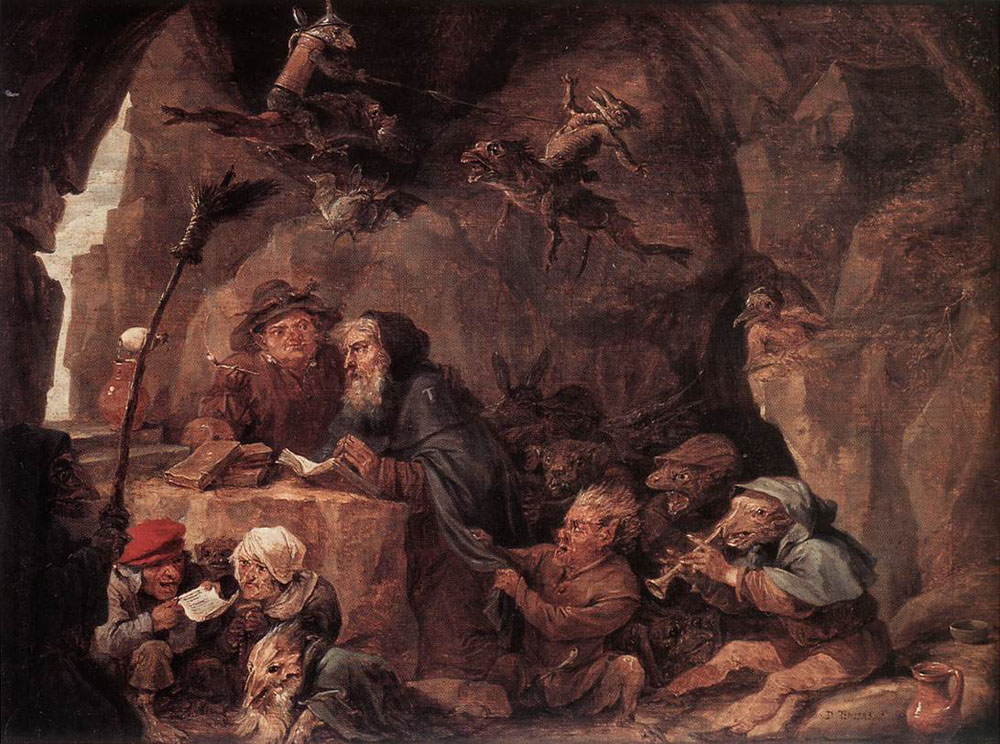How does the light play a role in this particular painting? The use of light is pivotal in this painting, typical of the Baroque period's style. Strategic placement of bright light sources contrasts sharply against the deep, absorbing shadows of the cave. This interplay not only enhances the three-dimensionality of the scene but also brings focus and life to the figures of the dwarves. It highlights their facial expressions and the textures of their clothing, making the scene vivid and the characters more relatable. Light, in this context, does more than illuminate; it animates and dramatizes, adding layers of meaning to the everyday activities taking place. 